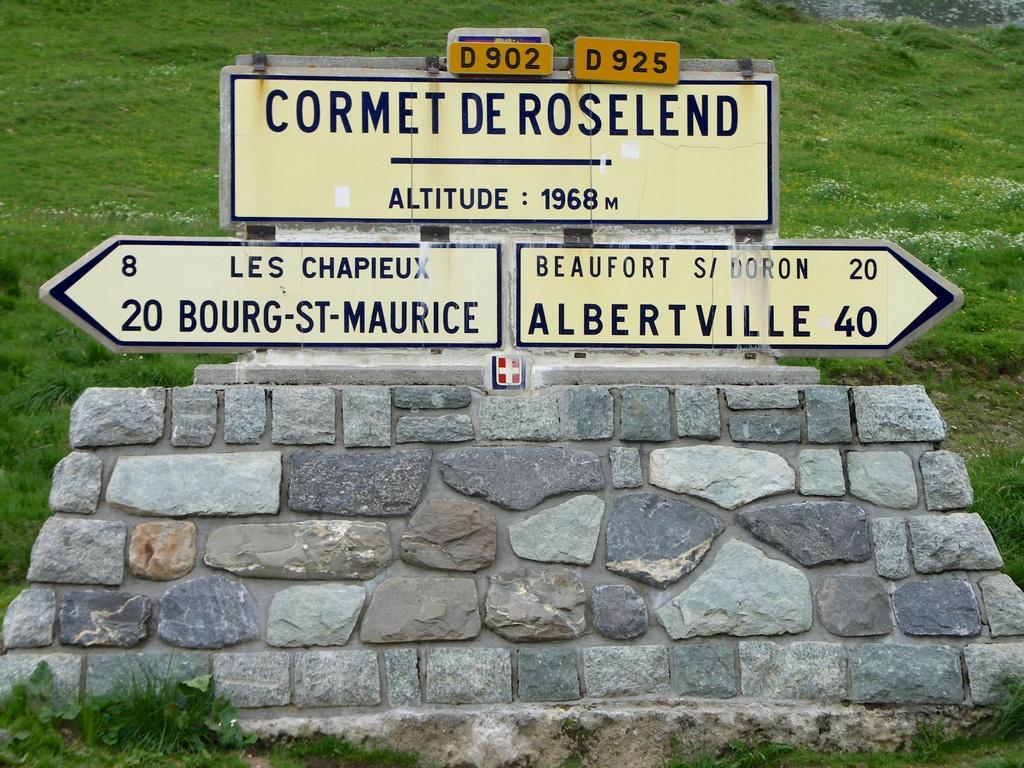<image>
Share a concise interpretation of the image provided. a sign that says cormet de roselend with other signs below it 